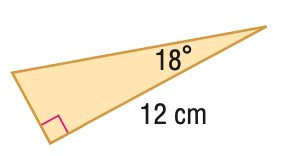Question: Find the perimeter of the triangle. Round to the nearest hundredth.
Choices:
A. 27.31
B. 28.52
C. 60.34
D. 61.55
Answer with the letter. Answer: B Question: Find the area of the triangle. Round to the nearest hundredth.
Choices:
A. 11.70
B. 23.39
C. 28.52
D. 46.79
Answer with the letter. Answer: B 